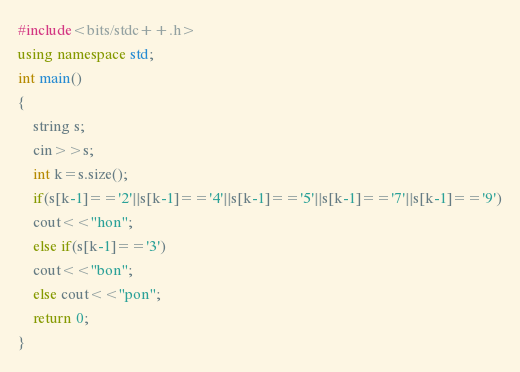Convert code to text. <code><loc_0><loc_0><loc_500><loc_500><_C++_>#include<bits/stdc++.h>
using namespace std;
int main()
{
	string s;
	cin>>s;
	int k=s.size();
	if(s[k-1]=='2'||s[k-1]=='4'||s[k-1]=='5'||s[k-1]=='7'||s[k-1]=='9')
	cout<<"hon";
	else if(s[k-1]=='3')
	cout<<"bon";
	else cout<<"pon";
	return 0;
}</code> 